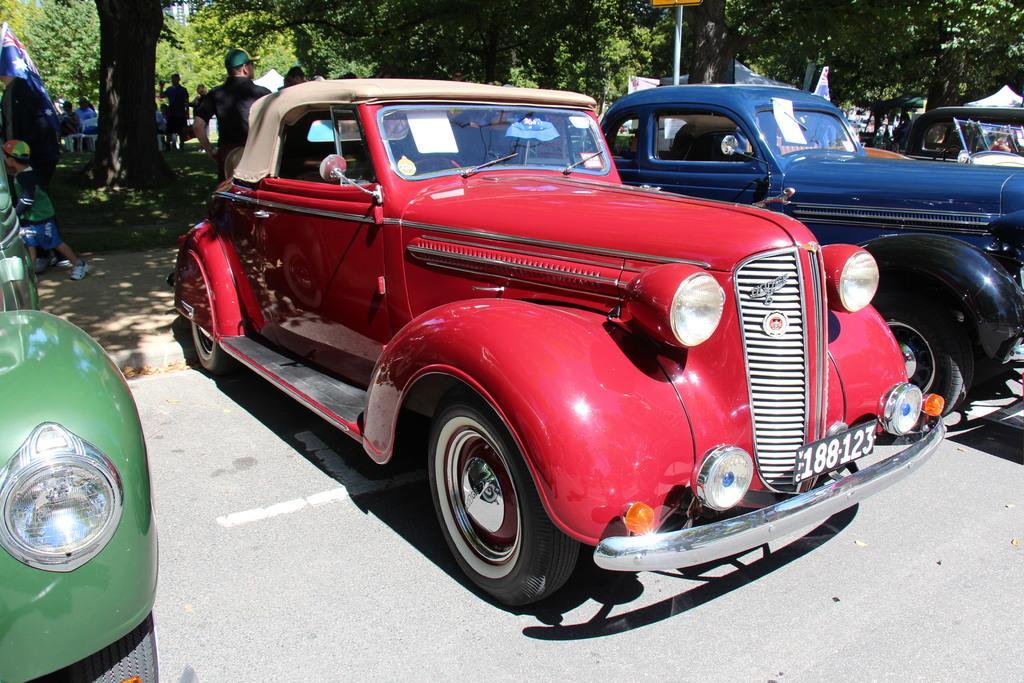Could you give a brief overview of what you see in this image? In this image, we can see few vehicles are parked on the road. Background we can see so many trees, people, poles, tents, grass, flag. 